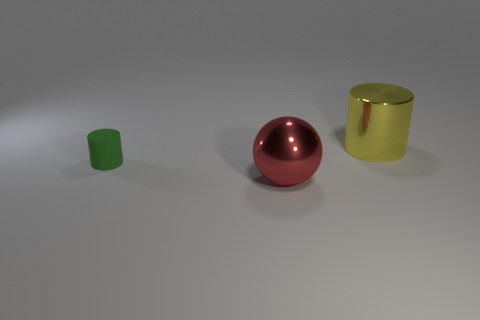Are there any other things that are made of the same material as the green cylinder?
Offer a very short reply. No. Is there anything else that has the same size as the green rubber cylinder?
Your answer should be compact. No. Are there any other things that are the same shape as the large red shiny thing?
Your answer should be very brief. No. There is a metallic thing in front of the rubber thing; is it the same shape as the yellow metallic thing?
Your answer should be compact. No. Is the number of objects to the left of the big shiny ball greater than the number of tiny green things behind the small green cylinder?
Provide a succinct answer. Yes. How many other things are the same size as the red ball?
Your answer should be very brief. 1. Does the big yellow metal object have the same shape as the small green thing to the left of the large yellow metallic thing?
Offer a terse response. Yes. What number of shiny objects are spheres or tiny things?
Provide a short and direct response. 1. Are there any blue metallic cubes?
Your response must be concise. No. Does the tiny object have the same shape as the big red thing?
Provide a succinct answer. No. 